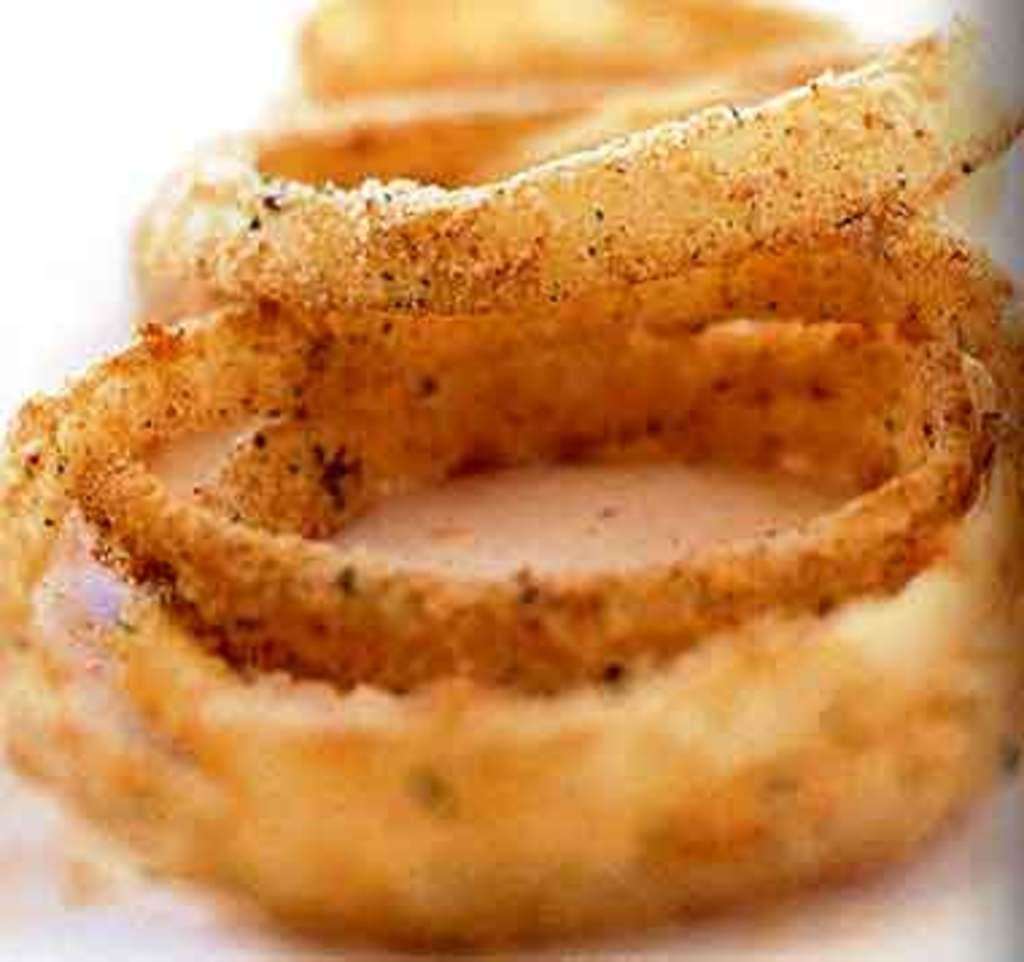What is the main subject of the image? There is a food item in the image. What type of meat is being served by the giraffe in the image? There is no giraffe present in the image, and no meat is mentioned in the provided fact. 